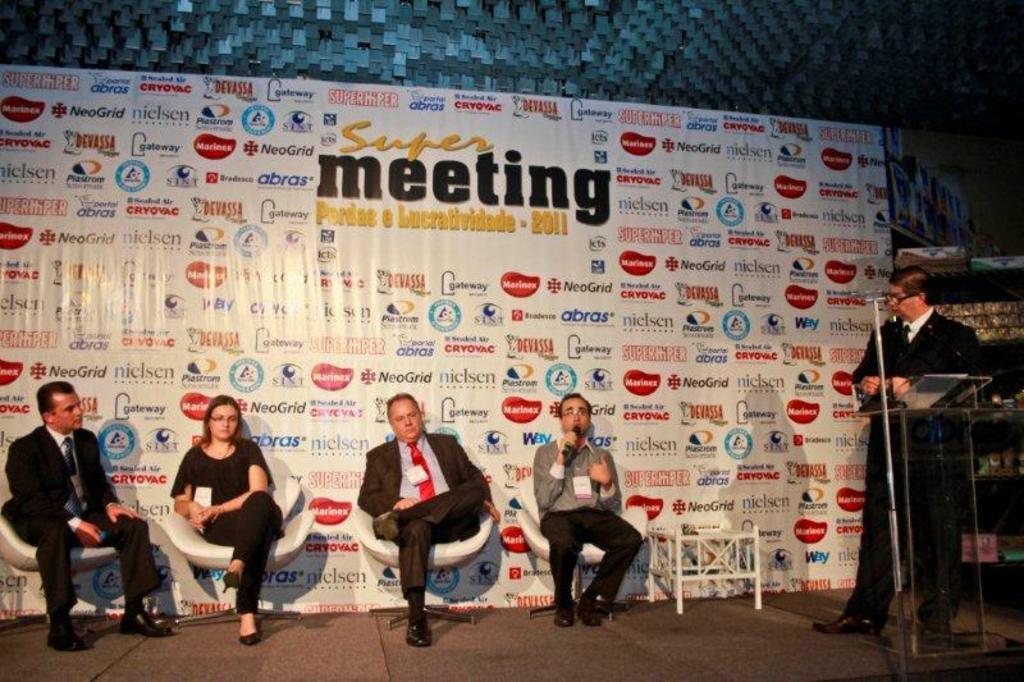How would you summarize this image in a sentence or two? In this picture we can see a man is standing behind the podium and on the left side of the man there are four people sitting on chairs. Behind the people there is a board. 